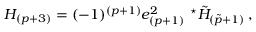Convert formula to latex. <formula><loc_0><loc_0><loc_500><loc_500>H _ { ( p + 3 ) } = ( - 1 ) ^ { ( p + 1 ) } e _ { ( p + 1 ) } ^ { 2 } ^ { ^ { * } } \tilde { H } _ { ( \tilde { p } + 1 ) } \, ,</formula> 